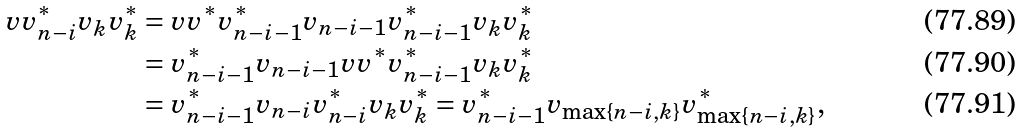Convert formula to latex. <formula><loc_0><loc_0><loc_500><loc_500>v v _ { n - i } ^ { * } v _ { k } v _ { k } ^ { * } & = v v ^ { * } v _ { n - i - 1 } ^ { * } v _ { n - i - 1 } v _ { n - i - 1 } ^ { * } v _ { k } v _ { k } ^ { * } \\ & = v _ { n - i - 1 } ^ { * } v _ { n - i - 1 } v v ^ { * } v _ { n - i - 1 } ^ { * } v _ { k } v _ { k } ^ { * } \\ & = v _ { n - i - 1 } ^ { * } v _ { n - i } v _ { n - i } ^ { * } v _ { k } v _ { k } ^ { * } = v _ { n - i - 1 } ^ { * } v _ { \max \{ n - i , k \} } v _ { \max \{ n - i , k \} } ^ { * } ,</formula> 